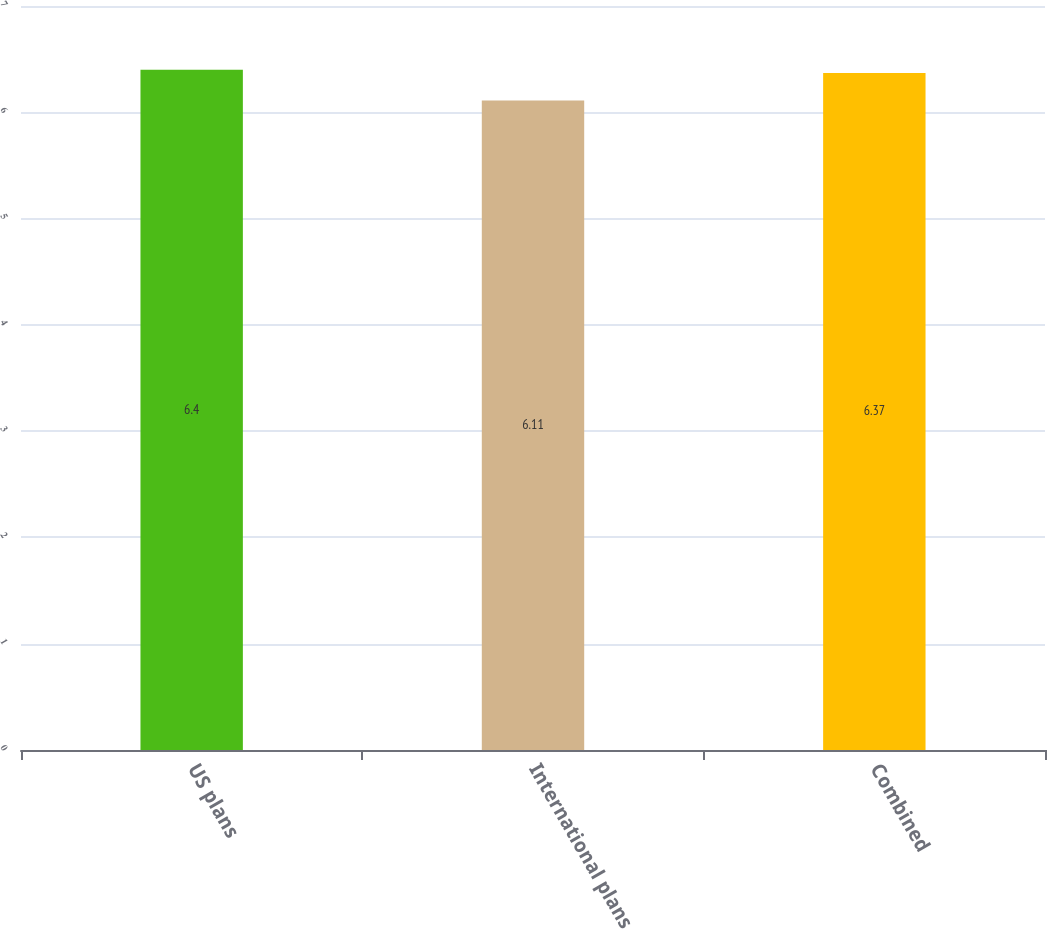<chart> <loc_0><loc_0><loc_500><loc_500><bar_chart><fcel>US plans<fcel>International plans<fcel>Combined<nl><fcel>6.4<fcel>6.11<fcel>6.37<nl></chart> 